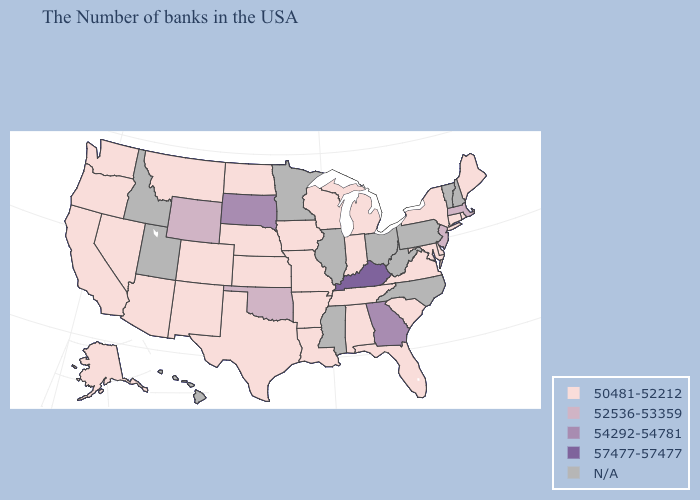Does Arizona have the highest value in the USA?
Answer briefly. No. What is the lowest value in the USA?
Be succinct. 50481-52212. Name the states that have a value in the range N/A?
Keep it brief. New Hampshire, Vermont, Pennsylvania, North Carolina, West Virginia, Ohio, Illinois, Mississippi, Minnesota, Utah, Idaho, Hawaii. Among the states that border Mississippi , which have the lowest value?
Short answer required. Alabama, Tennessee, Louisiana, Arkansas. What is the value of Nevada?
Concise answer only. 50481-52212. Name the states that have a value in the range 52536-53359?
Write a very short answer. Massachusetts, New Jersey, Oklahoma, Wyoming. What is the value of Louisiana?
Be succinct. 50481-52212. Name the states that have a value in the range 54292-54781?
Short answer required. Georgia, South Dakota. Is the legend a continuous bar?
Keep it brief. No. Name the states that have a value in the range 50481-52212?
Concise answer only. Maine, Rhode Island, Connecticut, New York, Delaware, Maryland, Virginia, South Carolina, Florida, Michigan, Indiana, Alabama, Tennessee, Wisconsin, Louisiana, Missouri, Arkansas, Iowa, Kansas, Nebraska, Texas, North Dakota, Colorado, New Mexico, Montana, Arizona, Nevada, California, Washington, Oregon, Alaska. Is the legend a continuous bar?
Answer briefly. No. Among the states that border Missouri , which have the lowest value?
Write a very short answer. Tennessee, Arkansas, Iowa, Kansas, Nebraska. What is the value of Massachusetts?
Quick response, please. 52536-53359. Name the states that have a value in the range 54292-54781?
Quick response, please. Georgia, South Dakota. What is the value of Iowa?
Answer briefly. 50481-52212. 